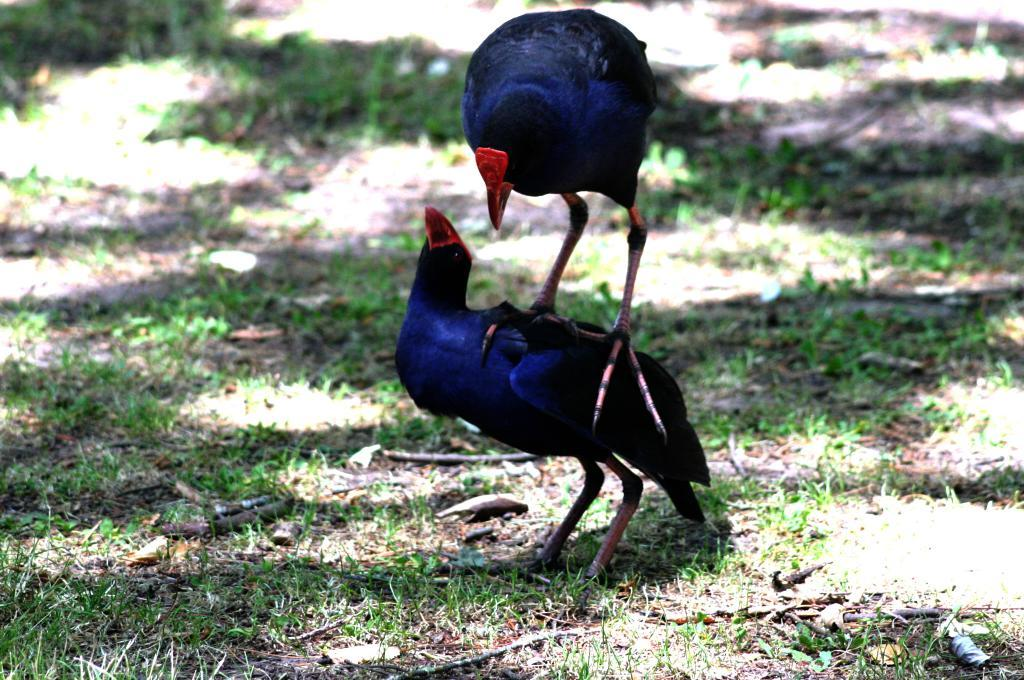How many birds are present in the image? There are two birds in the image. What type of natural environment is visible in the image? Grass is visible in the image. Where is the aunt sitting on the board in the image? There is no aunt or board present in the image; it features two birds and grass. What type of container is the quiver holding in the image? There is no quiver present in the image. 